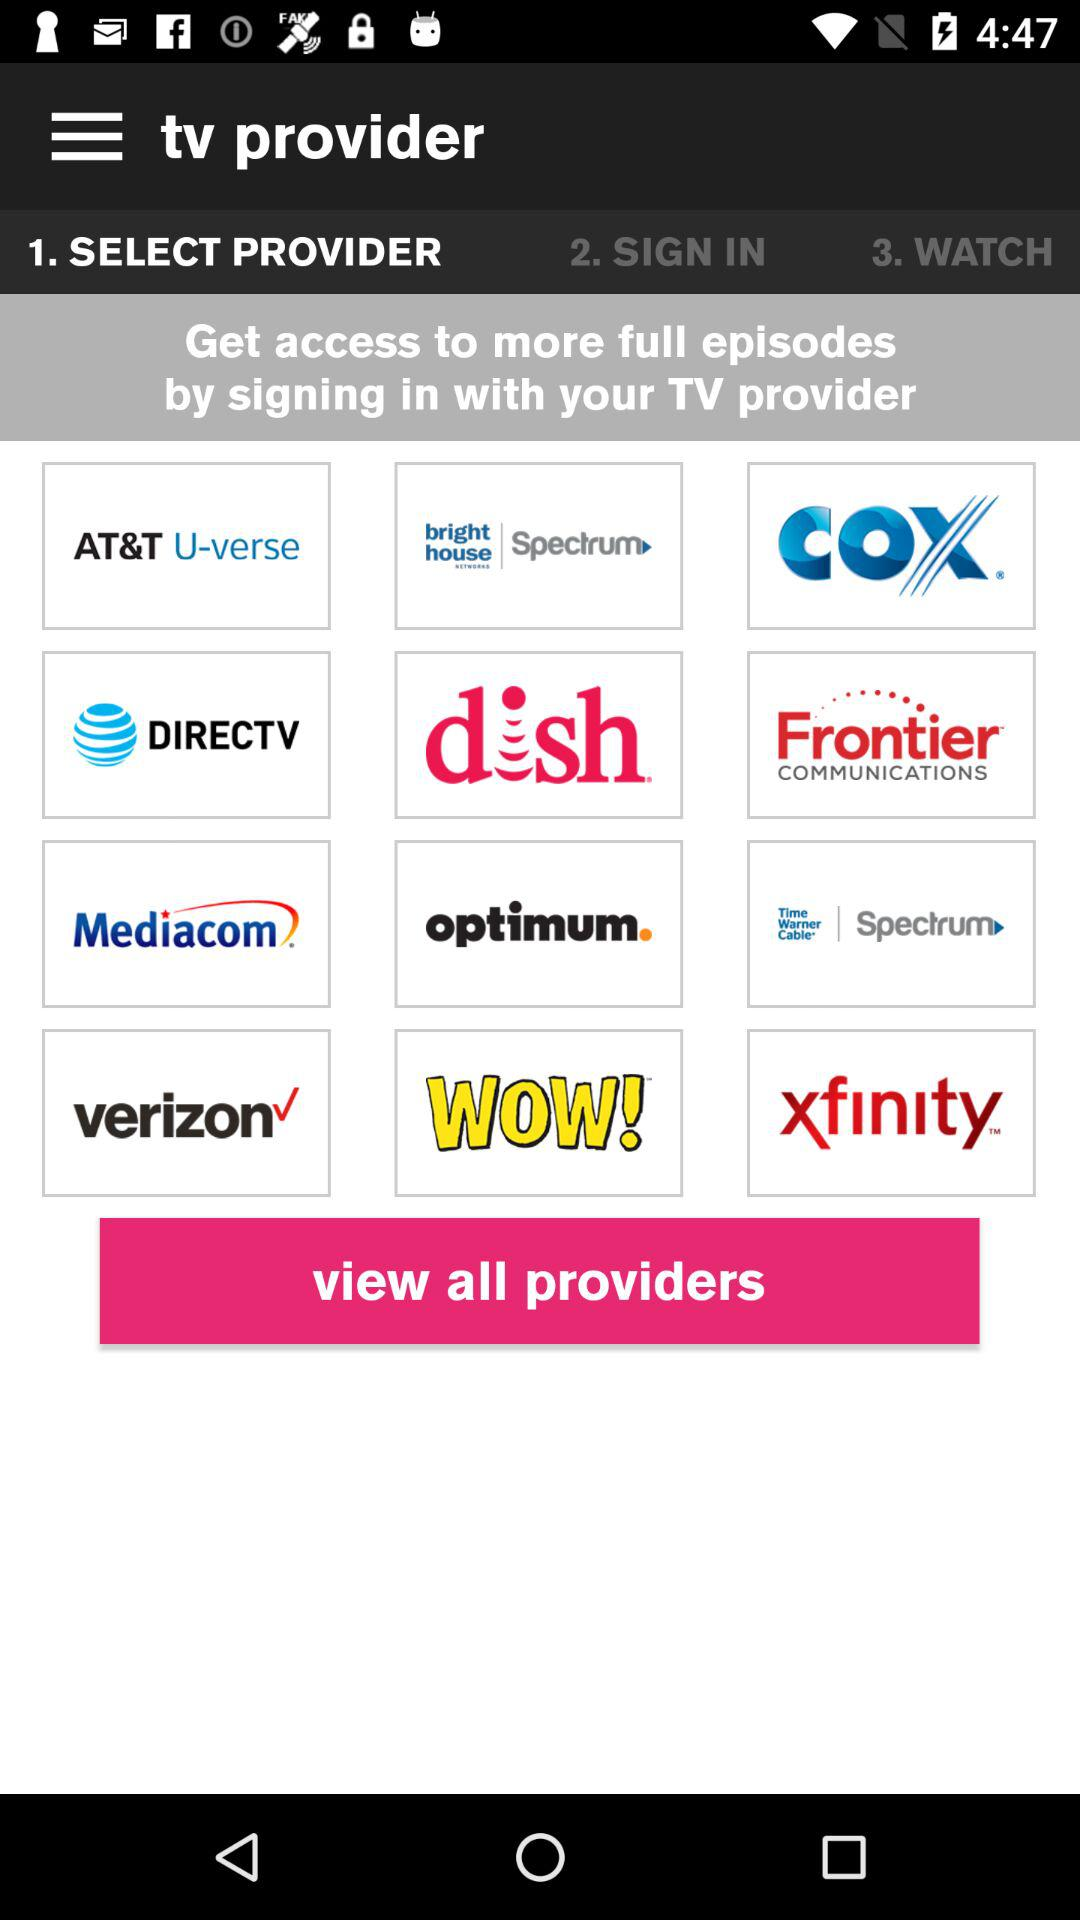Which provider is selected?
When the provided information is insufficient, respond with <no answer>. <no answer> 